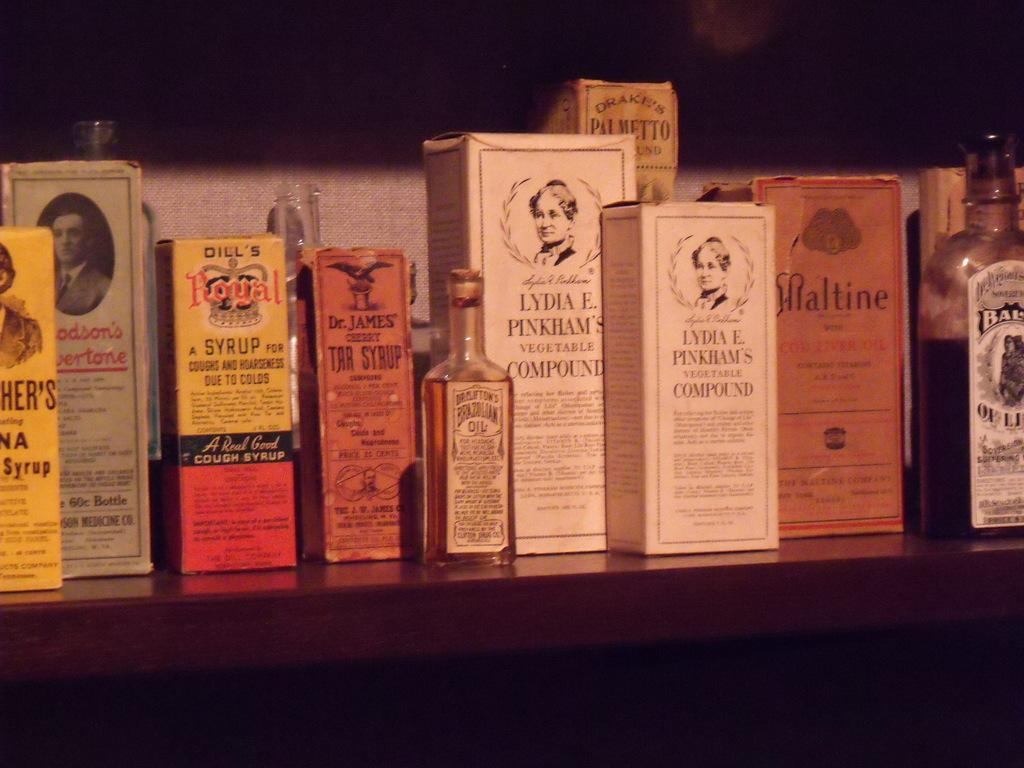<image>
Share a concise interpretation of the image provided. A shelf holding different syrups and compounds some in bottles and some in boxes. 